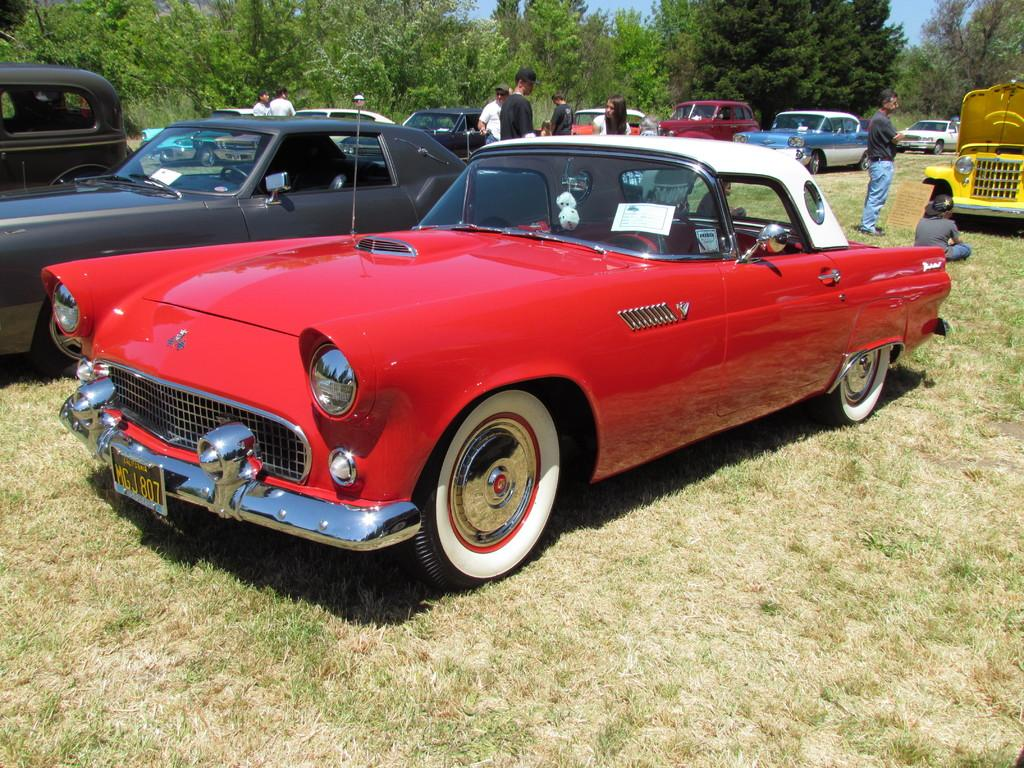What are the people in the image doing? The people in the image are standing on the ground. What else can be seen in the image besides the people? Motor vehicles are present in the image. What can be seen in the background of the image? There are trees and the sky visible in the background of the image. What historical event is being commemorated by the people in the image? There is no indication of a historical event being commemorated in the image; the people are simply standing on the ground. 